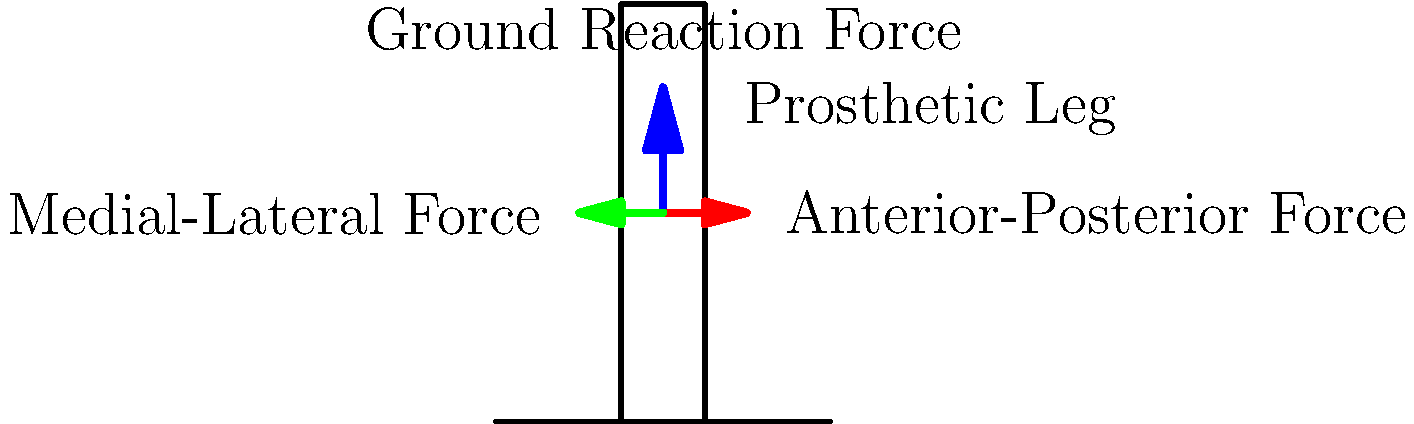As a business owner concerned about the impact of comic cons on local sales, you're considering diversifying into prosthetics. In analyzing the biomechanics of a prosthetic leg during walking, which force component typically has the smallest magnitude? To answer this question, let's break down the forces acting on a prosthetic leg during walking:

1. Vertical Ground Reaction Force (GRF):
   - This is the largest force component.
   - It counteracts the body weight and provides support during stance phase.
   - Typically ranges from 1-1.5 times body weight during normal walking.

2. Anterior-Posterior Force:
   - This force acts in the forward-backward direction.
   - It's smaller than the vertical GRF but still significant.
   - It helps with propulsion and braking during gait.
   - Generally ranges from 0.15-0.25 times body weight.

3. Medial-Lateral Force:
   - This force acts side-to-side.
   - It's the smallest of the three main force components.
   - It helps with balance and stability during walking.
   - Typically ranges from 0.05-0.1 times body weight.

Comparing these forces:

$$ \text{Vertical GRF} > \text{Anterior-Posterior Force} > \text{Medial-Lateral Force} $$

Therefore, the Medial-Lateral Force has the smallest magnitude among these components.
Answer: Medial-Lateral Force 